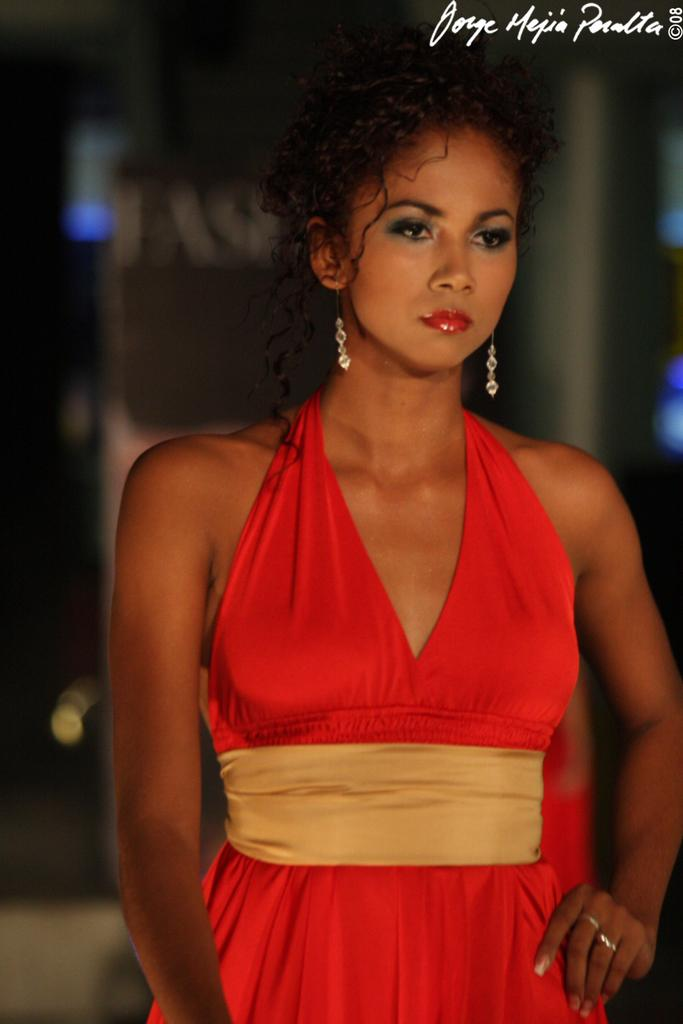Who is the main subject in the foreground of the picture? There is a woman in the foreground of the picture. What is the woman wearing in the image? The woman is wearing a red dress. What can be seen at the top of the image? There is some text at the top of the image. How would you describe the background of the image? The background of the image is blurred. Can you tell me how many horses are present in the image? There are no horses present in the image. What type of exchange is taking place between the woman and the horse in the image? There is no horse present in the image, and therefore no exchange can be observed. 